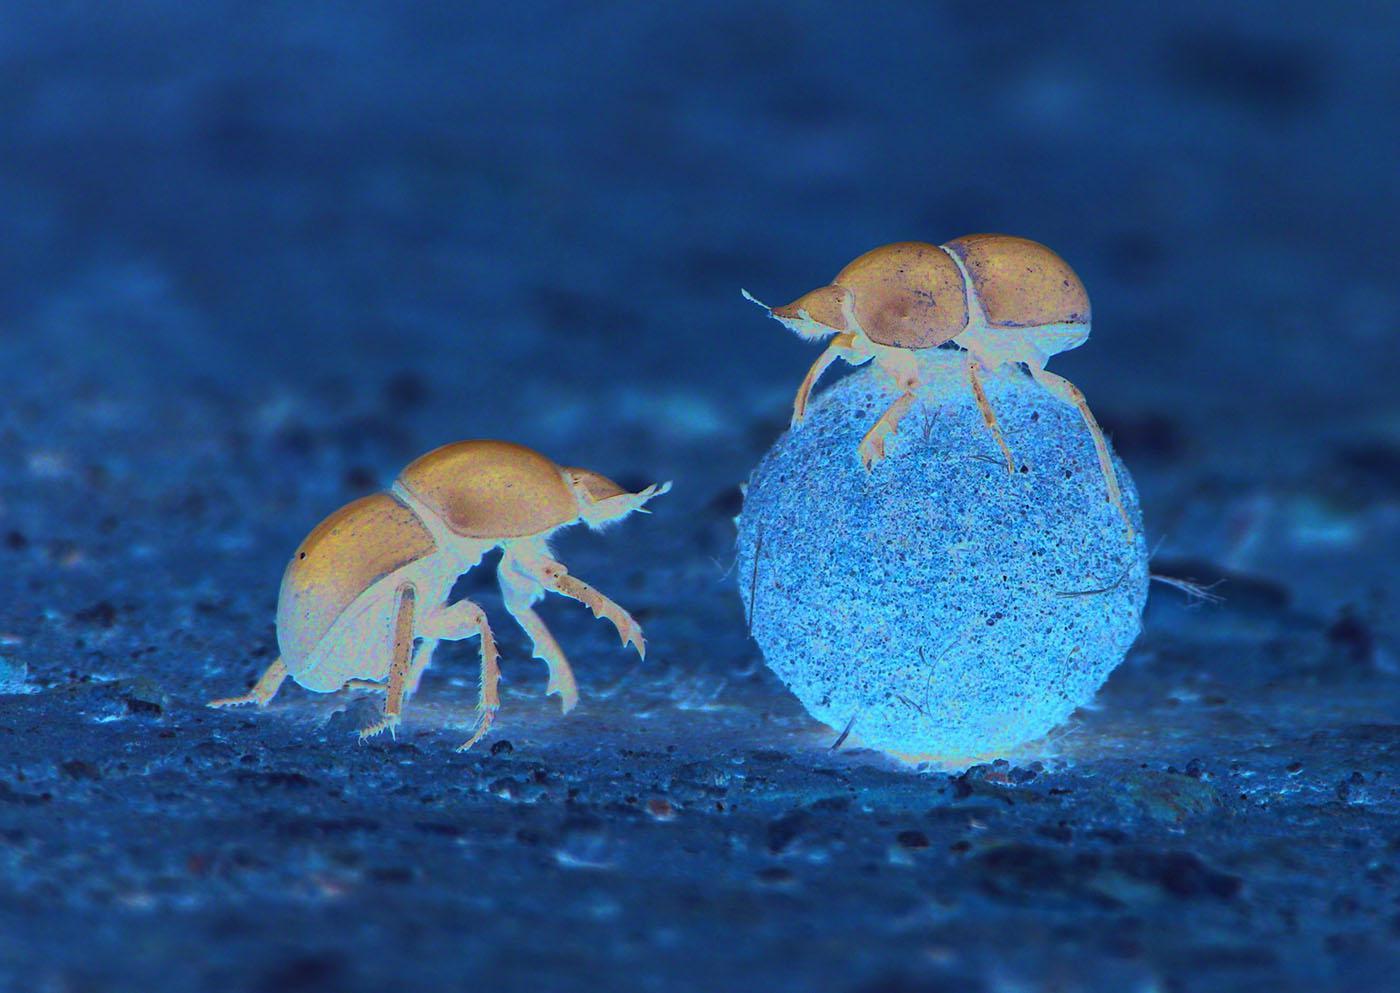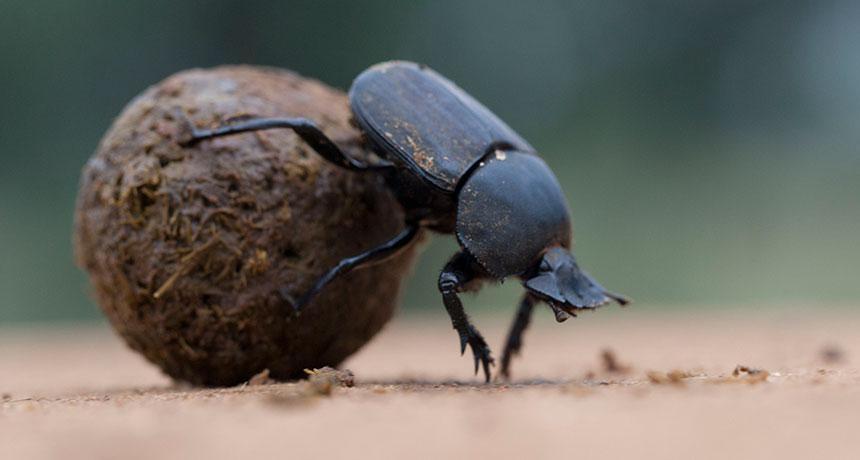The first image is the image on the left, the second image is the image on the right. Evaluate the accuracy of this statement regarding the images: "The photos contain a total of three beetles.". Is it true? Answer yes or no. Yes. The first image is the image on the left, the second image is the image on the right. Considering the images on both sides, is "There is only one dungball in the image pair." valid? Answer yes or no. No. The first image is the image on the left, the second image is the image on the right. Evaluate the accuracy of this statement regarding the images: "One image shows a beetle but no ball, and the other image shows a beetle partly perched on a ball.". Is it true? Answer yes or no. No. The first image is the image on the left, the second image is the image on the right. Examine the images to the left and right. Is the description "A beetle is perched on a ball with its front legs touching the ground on the right side of the image." accurate? Answer yes or no. Yes. The first image is the image on the left, the second image is the image on the right. Given the left and right images, does the statement "One image includes a beetle that is not in contact with a ball shape, and the other shows a beetle perched on a ball with its front legs touching the ground." hold true? Answer yes or no. Yes. The first image is the image on the left, the second image is the image on the right. Considering the images on both sides, is "There is a beetle that is not on a dung ball, in one image." valid? Answer yes or no. Yes. The first image is the image on the left, the second image is the image on the right. Examine the images to the left and right. Is the description "There is a bug in each image on a ball of sediment." accurate? Answer yes or no. Yes. The first image is the image on the left, the second image is the image on the right. Given the left and right images, does the statement "One beetle sits on the top of the clod of dirt in the image on the left." hold true? Answer yes or no. Yes. The first image is the image on the left, the second image is the image on the right. Assess this claim about the two images: "Two beetles are shown with a ball of dirt in one of the images.". Correct or not? Answer yes or no. Yes. The first image is the image on the left, the second image is the image on the right. Given the left and right images, does the statement "An image contains two dung beetles." hold true? Answer yes or no. Yes. The first image is the image on the left, the second image is the image on the right. Assess this claim about the two images: "There is no ball in the image on the left". Correct or not? Answer yes or no. No. The first image is the image on the left, the second image is the image on the right. Assess this claim about the two images: "One image includes a beetle that is not in contact with a ball shape.". Correct or not? Answer yes or no. Yes. 